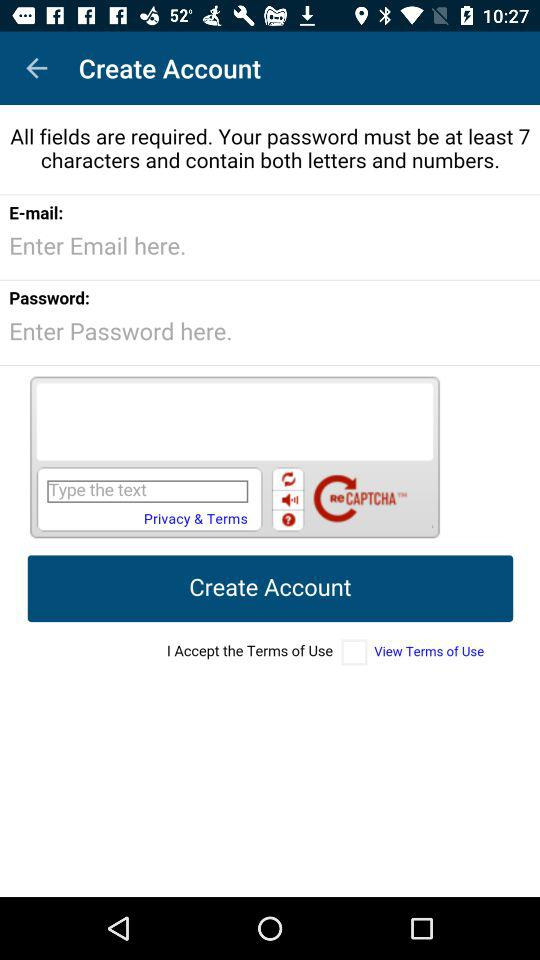What is the requirement for the password? The password "must be at least 7 characters and contain both letters and numbers". 